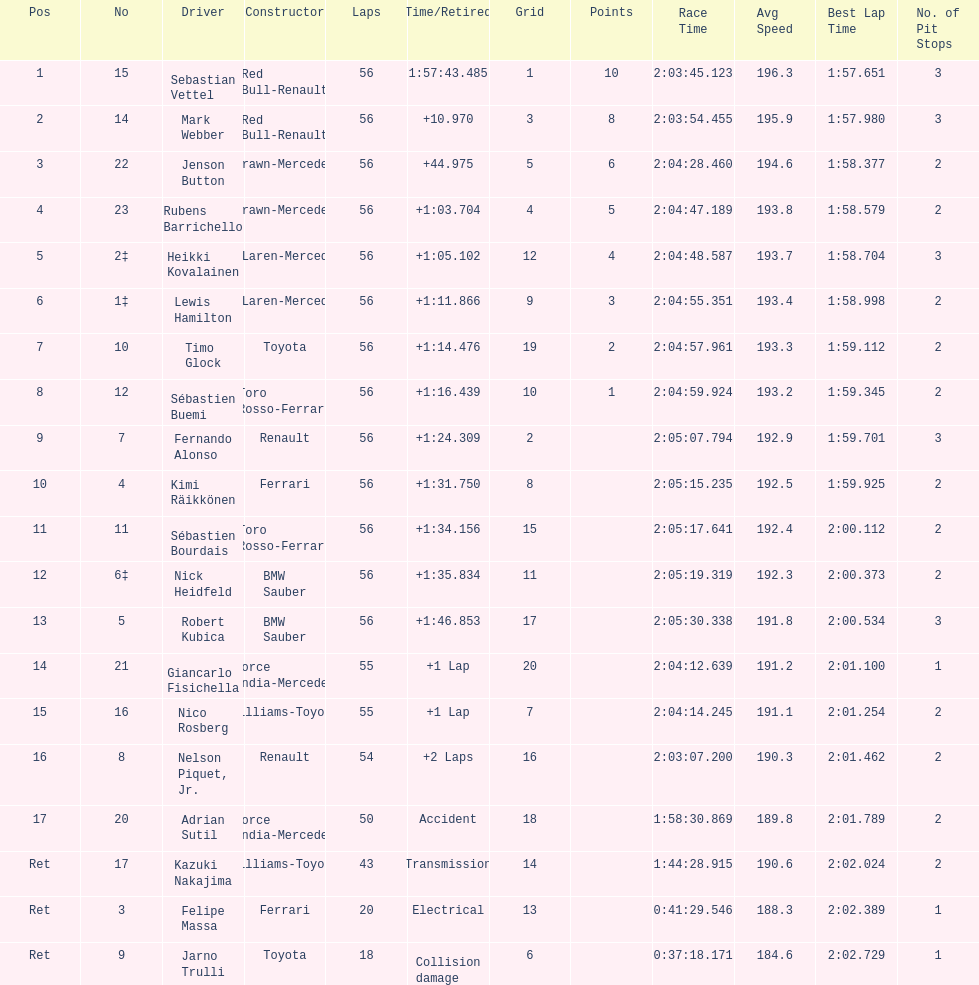Heikki kovalainen and lewis hamilton both had which constructor? McLaren-Mercedes. 